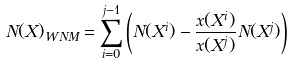Convert formula to latex. <formula><loc_0><loc_0><loc_500><loc_500>N ( X ) _ { W N M } = \sum _ { i = 0 } ^ { j - 1 } \left ( N ( X ^ { i } ) - \frac { x ( X ^ { i } ) } { x ( X ^ { j } ) } N ( X ^ { j } ) \right )</formula> 